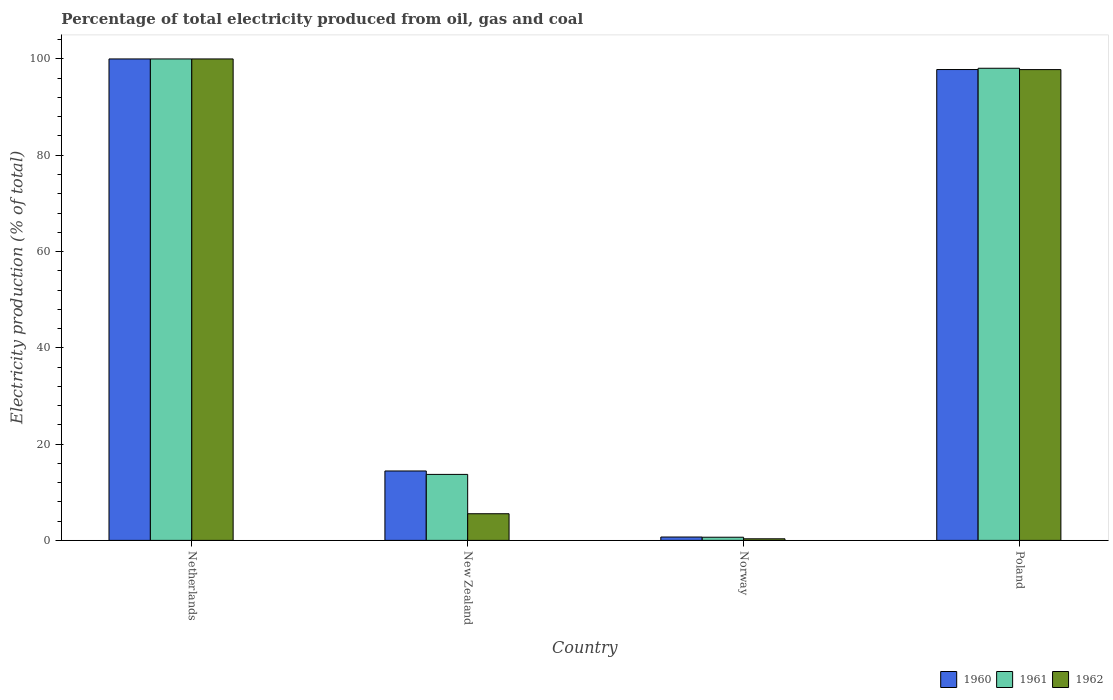How many groups of bars are there?
Provide a short and direct response. 4. Are the number of bars per tick equal to the number of legend labels?
Provide a short and direct response. Yes. Are the number of bars on each tick of the X-axis equal?
Provide a succinct answer. Yes. How many bars are there on the 4th tick from the left?
Provide a short and direct response. 3. In how many cases, is the number of bars for a given country not equal to the number of legend labels?
Your response must be concise. 0. What is the electricity production in in 1960 in Norway?
Make the answer very short. 0.7. Across all countries, what is the minimum electricity production in in 1961?
Offer a terse response. 0.66. In which country was the electricity production in in 1960 minimum?
Offer a very short reply. Norway. What is the total electricity production in in 1961 in the graph?
Provide a succinct answer. 212.43. What is the difference between the electricity production in in 1961 in Netherlands and that in New Zealand?
Your answer should be very brief. 86.29. What is the difference between the electricity production in in 1960 in Netherlands and the electricity production in in 1961 in Norway?
Provide a short and direct response. 99.34. What is the average electricity production in in 1960 per country?
Provide a short and direct response. 53.23. What is the difference between the electricity production in of/in 1960 and electricity production in of/in 1962 in Netherlands?
Provide a succinct answer. 0. What is the ratio of the electricity production in in 1961 in Norway to that in Poland?
Give a very brief answer. 0.01. Is the electricity production in in 1961 in Netherlands less than that in New Zealand?
Your response must be concise. No. Is the difference between the electricity production in in 1960 in Netherlands and Poland greater than the difference between the electricity production in in 1962 in Netherlands and Poland?
Make the answer very short. No. What is the difference between the highest and the second highest electricity production in in 1962?
Give a very brief answer. -2.21. What is the difference between the highest and the lowest electricity production in in 1961?
Ensure brevity in your answer.  99.34. In how many countries, is the electricity production in in 1960 greater than the average electricity production in in 1960 taken over all countries?
Offer a very short reply. 2. Is the sum of the electricity production in in 1961 in Netherlands and Poland greater than the maximum electricity production in in 1962 across all countries?
Offer a very short reply. Yes. What does the 1st bar from the left in New Zealand represents?
Offer a very short reply. 1960. What does the 1st bar from the right in Netherlands represents?
Keep it short and to the point. 1962. Is it the case that in every country, the sum of the electricity production in in 1962 and electricity production in in 1961 is greater than the electricity production in in 1960?
Provide a succinct answer. Yes. How many bars are there?
Your answer should be compact. 12. How many countries are there in the graph?
Offer a very short reply. 4. Does the graph contain any zero values?
Ensure brevity in your answer.  No. Does the graph contain grids?
Your answer should be compact. No. How many legend labels are there?
Give a very brief answer. 3. What is the title of the graph?
Ensure brevity in your answer.  Percentage of total electricity produced from oil, gas and coal. What is the label or title of the X-axis?
Keep it short and to the point. Country. What is the label or title of the Y-axis?
Provide a short and direct response. Electricity production (% of total). What is the Electricity production (% of total) of 1961 in Netherlands?
Make the answer very short. 100. What is the Electricity production (% of total) of 1962 in Netherlands?
Your answer should be compact. 100. What is the Electricity production (% of total) in 1960 in New Zealand?
Provide a succinct answer. 14.42. What is the Electricity production (% of total) of 1961 in New Zealand?
Give a very brief answer. 13.71. What is the Electricity production (% of total) of 1962 in New Zealand?
Ensure brevity in your answer.  5.54. What is the Electricity production (% of total) in 1960 in Norway?
Ensure brevity in your answer.  0.7. What is the Electricity production (% of total) in 1961 in Norway?
Your answer should be compact. 0.66. What is the Electricity production (% of total) of 1962 in Norway?
Your answer should be very brief. 0.33. What is the Electricity production (% of total) of 1960 in Poland?
Give a very brief answer. 97.8. What is the Electricity production (% of total) in 1961 in Poland?
Your response must be concise. 98.07. What is the Electricity production (% of total) of 1962 in Poland?
Your answer should be compact. 97.79. Across all countries, what is the maximum Electricity production (% of total) of 1960?
Keep it short and to the point. 100. Across all countries, what is the maximum Electricity production (% of total) in 1961?
Give a very brief answer. 100. Across all countries, what is the minimum Electricity production (% of total) of 1960?
Make the answer very short. 0.7. Across all countries, what is the minimum Electricity production (% of total) in 1961?
Your answer should be compact. 0.66. Across all countries, what is the minimum Electricity production (% of total) of 1962?
Keep it short and to the point. 0.33. What is the total Electricity production (% of total) in 1960 in the graph?
Offer a terse response. 212.92. What is the total Electricity production (% of total) of 1961 in the graph?
Offer a terse response. 212.43. What is the total Electricity production (% of total) in 1962 in the graph?
Your answer should be compact. 203.65. What is the difference between the Electricity production (% of total) of 1960 in Netherlands and that in New Zealand?
Offer a terse response. 85.58. What is the difference between the Electricity production (% of total) of 1961 in Netherlands and that in New Zealand?
Make the answer very short. 86.29. What is the difference between the Electricity production (% of total) of 1962 in Netherlands and that in New Zealand?
Make the answer very short. 94.46. What is the difference between the Electricity production (% of total) of 1960 in Netherlands and that in Norway?
Offer a terse response. 99.3. What is the difference between the Electricity production (% of total) of 1961 in Netherlands and that in Norway?
Your response must be concise. 99.34. What is the difference between the Electricity production (% of total) in 1962 in Netherlands and that in Norway?
Your answer should be very brief. 99.67. What is the difference between the Electricity production (% of total) of 1960 in Netherlands and that in Poland?
Give a very brief answer. 2.2. What is the difference between the Electricity production (% of total) of 1961 in Netherlands and that in Poland?
Your response must be concise. 1.93. What is the difference between the Electricity production (% of total) of 1962 in Netherlands and that in Poland?
Make the answer very short. 2.21. What is the difference between the Electricity production (% of total) in 1960 in New Zealand and that in Norway?
Your response must be concise. 13.72. What is the difference between the Electricity production (% of total) of 1961 in New Zealand and that in Norway?
Provide a short and direct response. 13.05. What is the difference between the Electricity production (% of total) of 1962 in New Zealand and that in Norway?
Give a very brief answer. 5.21. What is the difference between the Electricity production (% of total) of 1960 in New Zealand and that in Poland?
Offer a terse response. -83.38. What is the difference between the Electricity production (% of total) in 1961 in New Zealand and that in Poland?
Ensure brevity in your answer.  -84.36. What is the difference between the Electricity production (% of total) of 1962 in New Zealand and that in Poland?
Your answer should be compact. -92.25. What is the difference between the Electricity production (% of total) in 1960 in Norway and that in Poland?
Offer a terse response. -97.1. What is the difference between the Electricity production (% of total) in 1961 in Norway and that in Poland?
Ensure brevity in your answer.  -97.41. What is the difference between the Electricity production (% of total) of 1962 in Norway and that in Poland?
Your answer should be compact. -97.46. What is the difference between the Electricity production (% of total) in 1960 in Netherlands and the Electricity production (% of total) in 1961 in New Zealand?
Ensure brevity in your answer.  86.29. What is the difference between the Electricity production (% of total) in 1960 in Netherlands and the Electricity production (% of total) in 1962 in New Zealand?
Ensure brevity in your answer.  94.46. What is the difference between the Electricity production (% of total) in 1961 in Netherlands and the Electricity production (% of total) in 1962 in New Zealand?
Make the answer very short. 94.46. What is the difference between the Electricity production (% of total) of 1960 in Netherlands and the Electricity production (% of total) of 1961 in Norway?
Make the answer very short. 99.34. What is the difference between the Electricity production (% of total) of 1960 in Netherlands and the Electricity production (% of total) of 1962 in Norway?
Give a very brief answer. 99.67. What is the difference between the Electricity production (% of total) of 1961 in Netherlands and the Electricity production (% of total) of 1962 in Norway?
Offer a very short reply. 99.67. What is the difference between the Electricity production (% of total) in 1960 in Netherlands and the Electricity production (% of total) in 1961 in Poland?
Your response must be concise. 1.93. What is the difference between the Electricity production (% of total) of 1960 in Netherlands and the Electricity production (% of total) of 1962 in Poland?
Make the answer very short. 2.21. What is the difference between the Electricity production (% of total) of 1961 in Netherlands and the Electricity production (% of total) of 1962 in Poland?
Your answer should be compact. 2.21. What is the difference between the Electricity production (% of total) of 1960 in New Zealand and the Electricity production (% of total) of 1961 in Norway?
Offer a terse response. 13.76. What is the difference between the Electricity production (% of total) in 1960 in New Zealand and the Electricity production (% of total) in 1962 in Norway?
Offer a very short reply. 14.09. What is the difference between the Electricity production (% of total) in 1961 in New Zealand and the Electricity production (% of total) in 1962 in Norway?
Ensure brevity in your answer.  13.38. What is the difference between the Electricity production (% of total) of 1960 in New Zealand and the Electricity production (% of total) of 1961 in Poland?
Your answer should be very brief. -83.65. What is the difference between the Electricity production (% of total) in 1960 in New Zealand and the Electricity production (% of total) in 1962 in Poland?
Your answer should be very brief. -83.37. What is the difference between the Electricity production (% of total) of 1961 in New Zealand and the Electricity production (% of total) of 1962 in Poland?
Offer a terse response. -84.08. What is the difference between the Electricity production (% of total) of 1960 in Norway and the Electricity production (% of total) of 1961 in Poland?
Your answer should be very brief. -97.37. What is the difference between the Electricity production (% of total) of 1960 in Norway and the Electricity production (% of total) of 1962 in Poland?
Your answer should be very brief. -97.09. What is the difference between the Electricity production (% of total) in 1961 in Norway and the Electricity production (% of total) in 1962 in Poland?
Your answer should be compact. -97.13. What is the average Electricity production (% of total) in 1960 per country?
Make the answer very short. 53.23. What is the average Electricity production (% of total) in 1961 per country?
Your answer should be very brief. 53.11. What is the average Electricity production (% of total) of 1962 per country?
Offer a terse response. 50.91. What is the difference between the Electricity production (% of total) in 1961 and Electricity production (% of total) in 1962 in Netherlands?
Offer a very short reply. 0. What is the difference between the Electricity production (% of total) of 1960 and Electricity production (% of total) of 1961 in New Zealand?
Provide a short and direct response. 0.71. What is the difference between the Electricity production (% of total) of 1960 and Electricity production (% of total) of 1962 in New Zealand?
Offer a terse response. 8.88. What is the difference between the Electricity production (% of total) of 1961 and Electricity production (% of total) of 1962 in New Zealand?
Your answer should be very brief. 8.17. What is the difference between the Electricity production (% of total) of 1960 and Electricity production (% of total) of 1961 in Norway?
Your answer should be compact. 0.04. What is the difference between the Electricity production (% of total) in 1960 and Electricity production (% of total) in 1962 in Norway?
Your response must be concise. 0.37. What is the difference between the Electricity production (% of total) in 1961 and Electricity production (% of total) in 1962 in Norway?
Make the answer very short. 0.33. What is the difference between the Electricity production (% of total) in 1960 and Electricity production (% of total) in 1961 in Poland?
Offer a very short reply. -0.27. What is the difference between the Electricity production (% of total) in 1960 and Electricity production (% of total) in 1962 in Poland?
Your response must be concise. 0.01. What is the difference between the Electricity production (% of total) of 1961 and Electricity production (% of total) of 1962 in Poland?
Provide a short and direct response. 0.28. What is the ratio of the Electricity production (% of total) of 1960 in Netherlands to that in New Zealand?
Make the answer very short. 6.94. What is the ratio of the Electricity production (% of total) of 1961 in Netherlands to that in New Zealand?
Ensure brevity in your answer.  7.29. What is the ratio of the Electricity production (% of total) in 1962 in Netherlands to that in New Zealand?
Keep it short and to the point. 18.06. What is the ratio of the Electricity production (% of total) in 1960 in Netherlands to that in Norway?
Your response must be concise. 142.93. What is the ratio of the Electricity production (% of total) in 1961 in Netherlands to that in Norway?
Give a very brief answer. 152.21. What is the ratio of the Electricity production (% of total) of 1962 in Netherlands to that in Norway?
Provide a short and direct response. 302.6. What is the ratio of the Electricity production (% of total) of 1960 in Netherlands to that in Poland?
Make the answer very short. 1.02. What is the ratio of the Electricity production (% of total) of 1961 in Netherlands to that in Poland?
Provide a short and direct response. 1.02. What is the ratio of the Electricity production (% of total) in 1962 in Netherlands to that in Poland?
Give a very brief answer. 1.02. What is the ratio of the Electricity production (% of total) of 1960 in New Zealand to that in Norway?
Ensure brevity in your answer.  20.61. What is the ratio of the Electricity production (% of total) of 1961 in New Zealand to that in Norway?
Provide a succinct answer. 20.87. What is the ratio of the Electricity production (% of total) of 1962 in New Zealand to that in Norway?
Your answer should be very brief. 16.75. What is the ratio of the Electricity production (% of total) in 1960 in New Zealand to that in Poland?
Offer a very short reply. 0.15. What is the ratio of the Electricity production (% of total) in 1961 in New Zealand to that in Poland?
Make the answer very short. 0.14. What is the ratio of the Electricity production (% of total) in 1962 in New Zealand to that in Poland?
Offer a very short reply. 0.06. What is the ratio of the Electricity production (% of total) in 1960 in Norway to that in Poland?
Your answer should be compact. 0.01. What is the ratio of the Electricity production (% of total) of 1961 in Norway to that in Poland?
Ensure brevity in your answer.  0.01. What is the ratio of the Electricity production (% of total) in 1962 in Norway to that in Poland?
Your answer should be compact. 0. What is the difference between the highest and the second highest Electricity production (% of total) in 1960?
Keep it short and to the point. 2.2. What is the difference between the highest and the second highest Electricity production (% of total) in 1961?
Your answer should be compact. 1.93. What is the difference between the highest and the second highest Electricity production (% of total) of 1962?
Give a very brief answer. 2.21. What is the difference between the highest and the lowest Electricity production (% of total) in 1960?
Your answer should be very brief. 99.3. What is the difference between the highest and the lowest Electricity production (% of total) in 1961?
Offer a very short reply. 99.34. What is the difference between the highest and the lowest Electricity production (% of total) in 1962?
Your response must be concise. 99.67. 